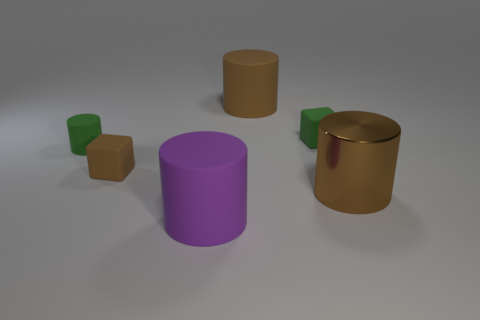The matte cylinder that is right of the tiny brown rubber cube and in front of the small green rubber cube is what color?
Offer a very short reply. Purple. Is the number of tiny purple matte cubes less than the number of large matte things?
Your answer should be very brief. Yes. There is a tiny cylinder; does it have the same color as the matte cube that is right of the purple thing?
Offer a terse response. Yes. Is the number of small rubber cylinders that are to the right of the small green cube the same as the number of large brown matte things that are left of the brown block?
Your answer should be compact. Yes. What number of cyan things have the same shape as the big brown matte thing?
Ensure brevity in your answer.  0. Are there any small blue balls?
Your response must be concise. No. Do the green cylinder and the large brown cylinder that is in front of the brown cube have the same material?
Offer a terse response. No. What is the material of the other brown cylinder that is the same size as the brown matte cylinder?
Ensure brevity in your answer.  Metal. Is there a large purple thing made of the same material as the tiny brown object?
Ensure brevity in your answer.  Yes. There is a rubber block in front of the green object that is left of the large purple thing; are there any green matte objects that are right of it?
Offer a terse response. Yes. 